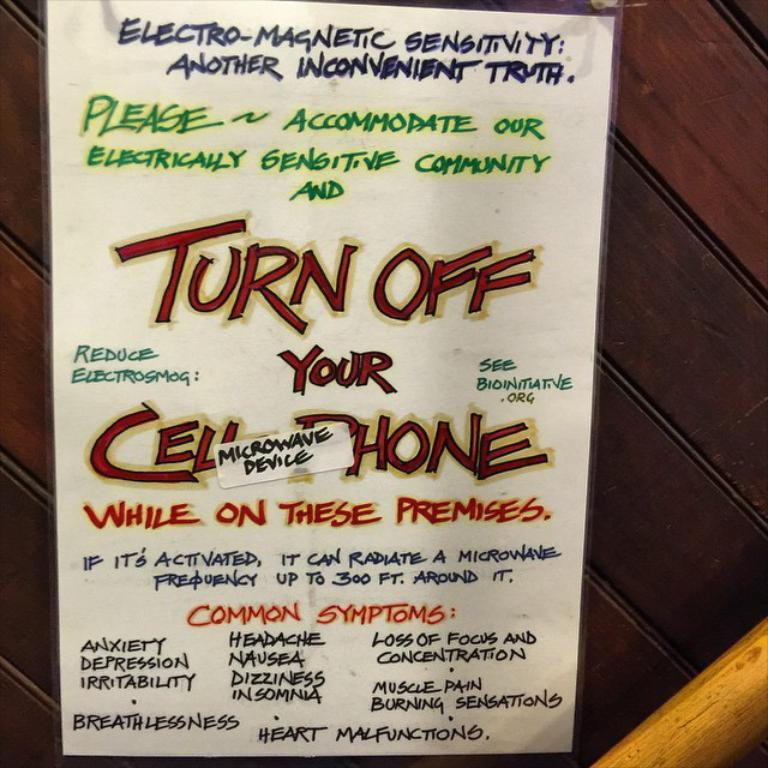<image>
Render a clear and concise summary of the photo. A handwritten sign implores people to turn off their cellphones. 